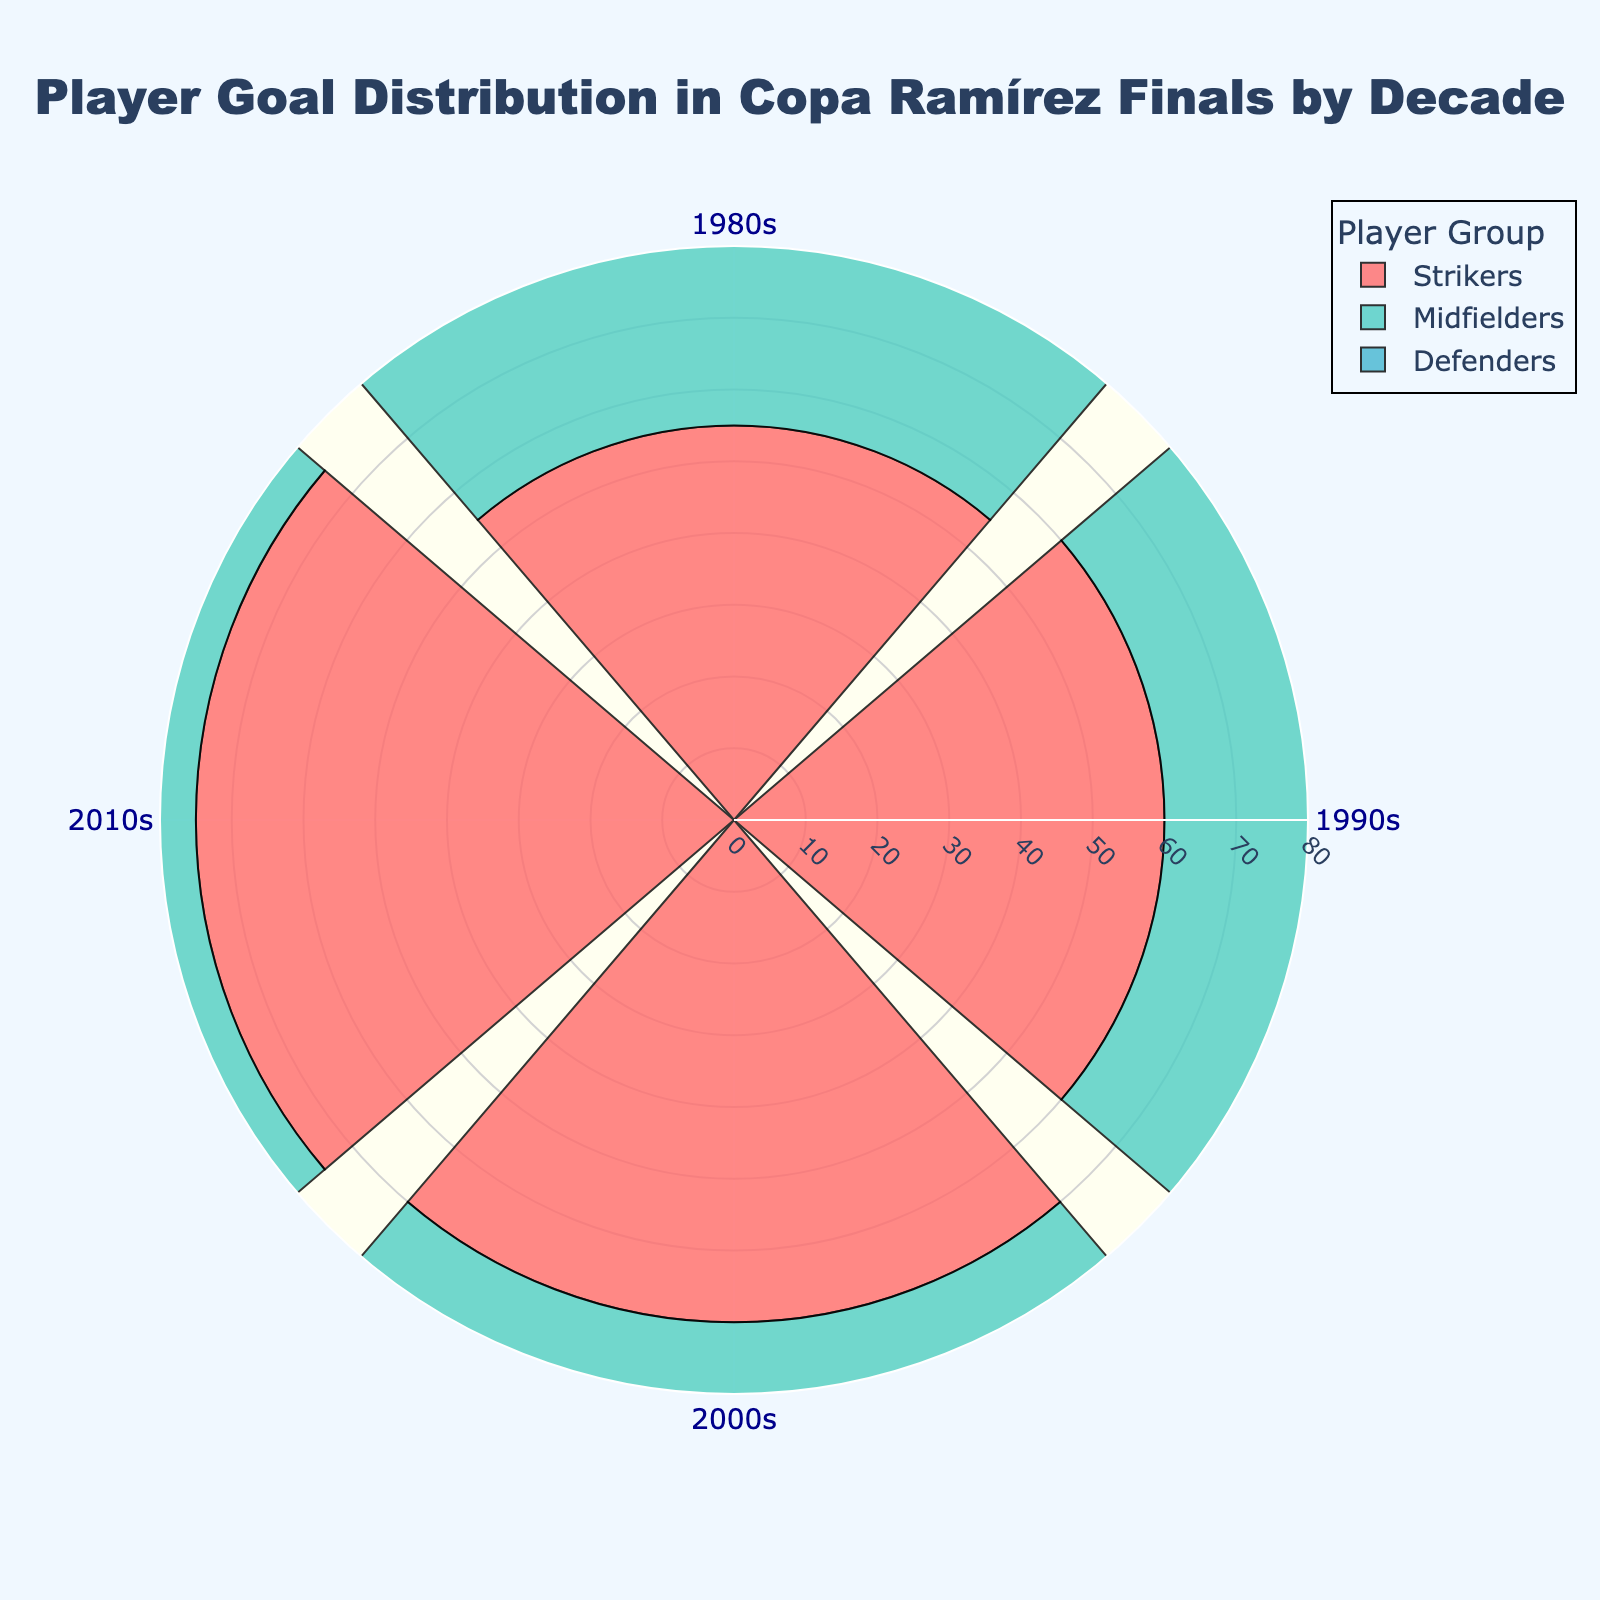What is the title of the figure? The title of the figure is shown at the top center and reads "Player Goal Distribution in Copa Ramírez Finals by Decade".
Answer: Player Goal Distribution in Copa Ramírez Finals by Decade How many player groups are represented in the chart? The chart has three distinct player groups represented by different colors: Strikers, Midfielders, and Defenders.
Answer: 3 What are the colors associated with each player group? The chart uses colors to differentiate between the player groups: Strikers are red, Midfielders are teal, and Defenders are blue.
Answer: Red, teal, blue Which player group had the highest number of goals in the 2010s? By looking at the goal values for each player group in the 2010s segment of the chart, Strikers had the most goals with a value of 75.
Answer: Strikers How many goals did the Defenders score in the 2000s? By referring to the 2000s segment of the Defenders group, we can see that Defenders scored 20 goals.
Answer: 20 Compare the goals scored by Strikers in the 1990s and the 1980s. Which decade had more goals and by how much? Strikers scored 60 goals in the 1990s and 55 goals in the 1980s. Subtracting these gives 60 - 55 = 5 more goals in the 1990s.
Answer: 1990s by 5 What is the sum of goals scored by Midfielders across all decades shown? Adding the goals scored by Midfielders: 30 (1980s) + 35 (1990s) + 40 (2000s) + 45 (2010s) = 150 goals.
Answer: 150 Which player group showed consistent growth in goals over each decade? By examining the trends, all player groups (Strikers, Midfielders, Defenders) show consistent growth in their goal numbers over the decades, but the least growth remains consistent for the Defenders.
Answer: All groups, least growth in Defenders Among the player groups, which had the smallest increase in goal count from the 1980s to the 2010s? From the values, Strikers increased by 20 (75-55), Midfielders by 15 (45-30), and Defenders by 15 (25-10). Defenders had the smallest increase, 15.
Answer: Defenders What is the total number of goals scored by all player groups in the 1990s? Summing the values for each group in the 1990s: Strikers (60) + Midfielders (35) + Defenders (15) = 110 goals.
Answer: 110 